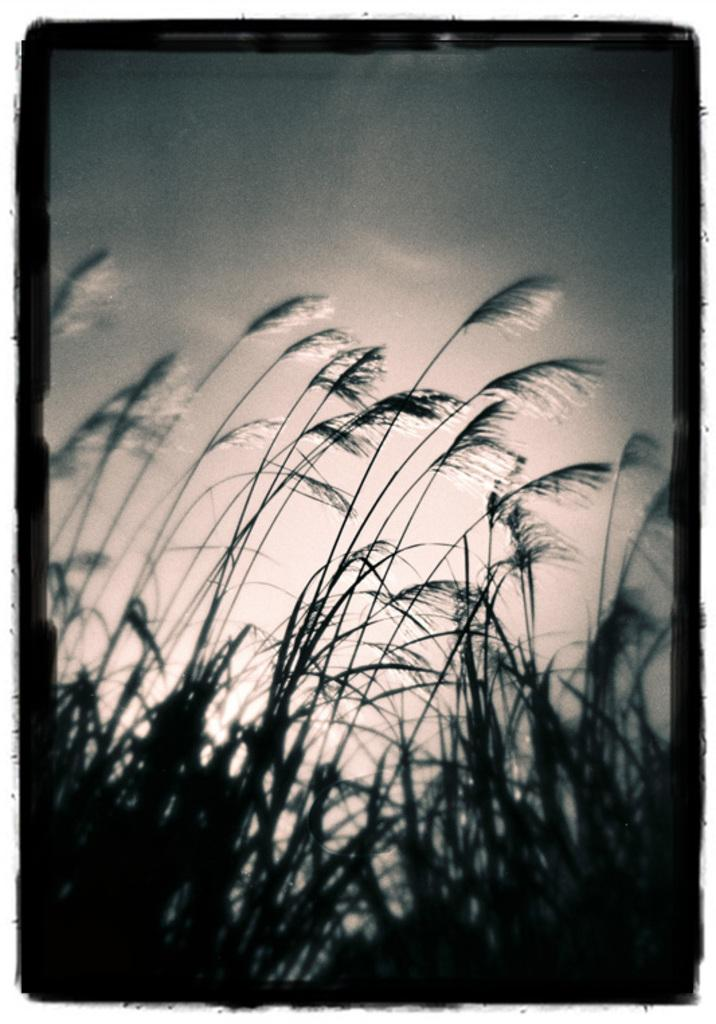What type of living organisms can be seen in the image? Plants can be seen in the image. What part of the natural environment is visible in the image? The sky is visible in the image. What color is used for the borders of the image? The borders of the image are black in color. What type of activity is taking place in the field in the image? There is no field present in the image, only plants and the sky are visible. 